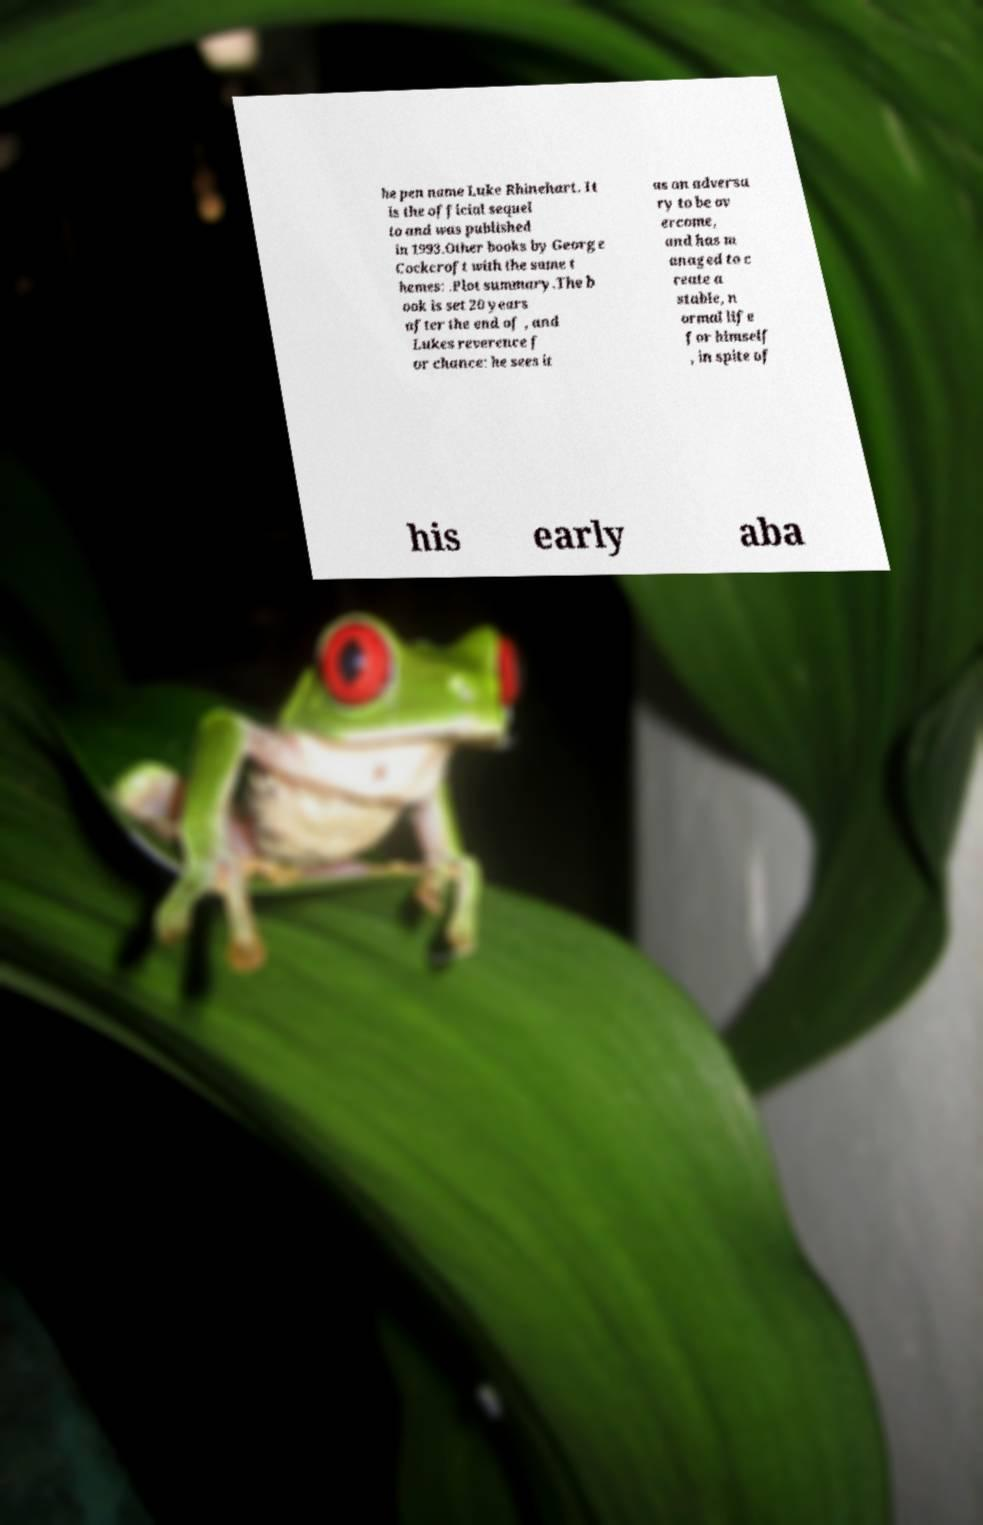Please identify and transcribe the text found in this image. he pen name Luke Rhinehart. It is the official sequel to and was published in 1993.Other books by George Cockcroft with the same t hemes: .Plot summary.The b ook is set 20 years after the end of , and Lukes reverence f or chance: he sees it as an adversa ry to be ov ercome, and has m anaged to c reate a stable, n ormal life for himself , in spite of his early aba 